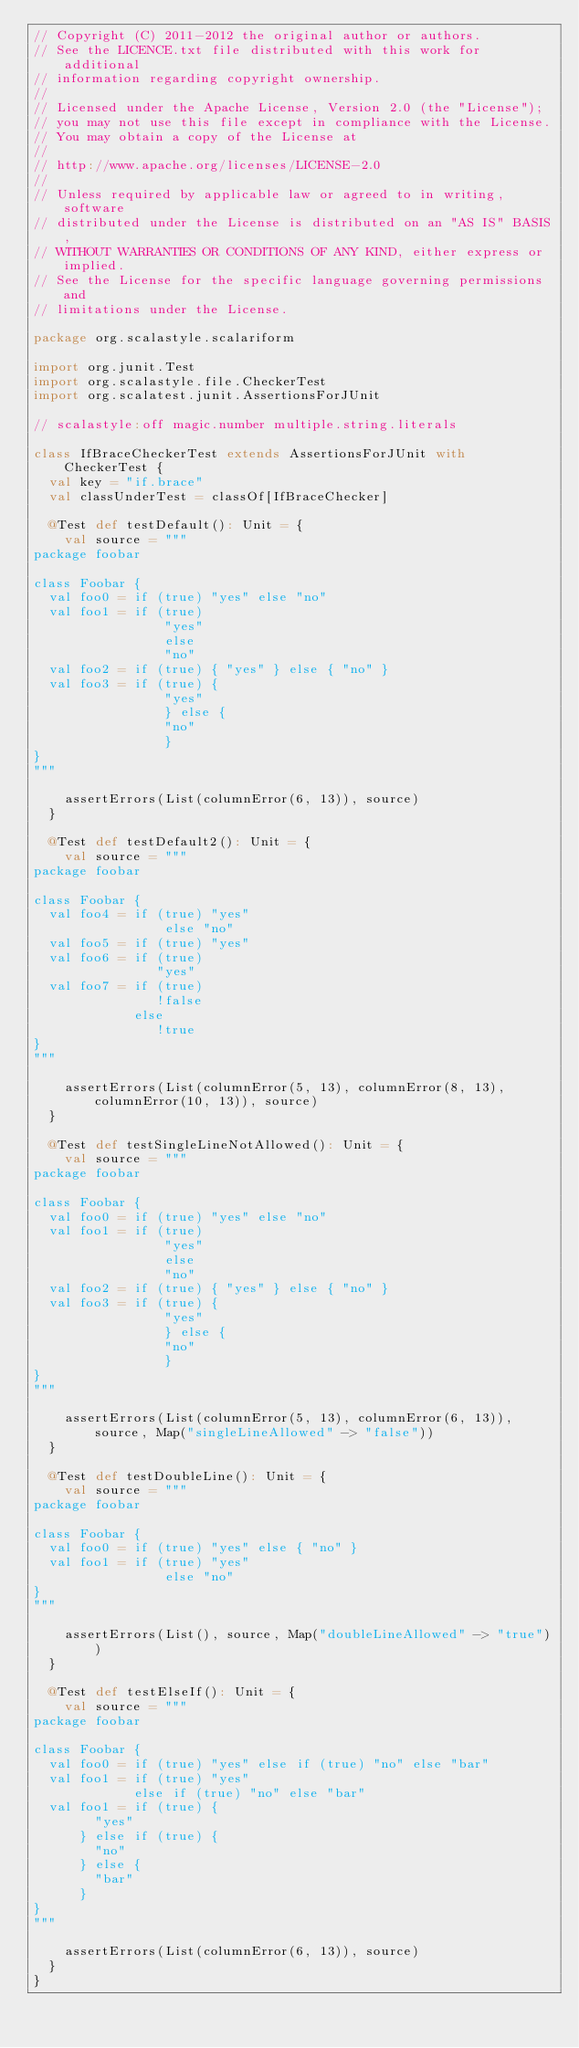Convert code to text. <code><loc_0><loc_0><loc_500><loc_500><_Scala_>// Copyright (C) 2011-2012 the original author or authors.
// See the LICENCE.txt file distributed with this work for additional
// information regarding copyright ownership.
//
// Licensed under the Apache License, Version 2.0 (the "License");
// you may not use this file except in compliance with the License.
// You may obtain a copy of the License at
//
// http://www.apache.org/licenses/LICENSE-2.0
//
// Unless required by applicable law or agreed to in writing, software
// distributed under the License is distributed on an "AS IS" BASIS,
// WITHOUT WARRANTIES OR CONDITIONS OF ANY KIND, either express or implied.
// See the License for the specific language governing permissions and
// limitations under the License.

package org.scalastyle.scalariform

import org.junit.Test
import org.scalastyle.file.CheckerTest
import org.scalatest.junit.AssertionsForJUnit

// scalastyle:off magic.number multiple.string.literals

class IfBraceCheckerTest extends AssertionsForJUnit with CheckerTest {
  val key = "if.brace"
  val classUnderTest = classOf[IfBraceChecker]

  @Test def testDefault(): Unit = {
    val source = """
package foobar

class Foobar {
  val foo0 = if (true) "yes" else "no"
  val foo1 = if (true)
                 "yes"
                 else
                 "no"
  val foo2 = if (true) { "yes" } else { "no" }
  val foo3 = if (true) {
                 "yes"
                 } else {
                 "no"
                 }
}
"""

    assertErrors(List(columnError(6, 13)), source)
  }

  @Test def testDefault2(): Unit = {
    val source = """
package foobar

class Foobar {
  val foo4 = if (true) "yes"
                 else "no"
  val foo5 = if (true) "yes"
  val foo6 = if (true)
                "yes"
  val foo7 = if (true)
                !false
             else
                !true
}
"""

    assertErrors(List(columnError(5, 13), columnError(8, 13), columnError(10, 13)), source)
  }

  @Test def testSingleLineNotAllowed(): Unit = {
    val source = """
package foobar

class Foobar {
  val foo0 = if (true) "yes" else "no"
  val foo1 = if (true)
                 "yes"
                 else
                 "no"
  val foo2 = if (true) { "yes" } else { "no" }
  val foo3 = if (true) {
                 "yes"
                 } else {
                 "no"
                 }
}
"""

    assertErrors(List(columnError(5, 13), columnError(6, 13)), source, Map("singleLineAllowed" -> "false"))
  }

  @Test def testDoubleLine(): Unit = {
    val source = """
package foobar

class Foobar {
  val foo0 = if (true) "yes" else { "no" }
  val foo1 = if (true) "yes"
                 else "no"
}
"""

    assertErrors(List(), source, Map("doubleLineAllowed" -> "true"))
  }

  @Test def testElseIf(): Unit = {
    val source = """
package foobar

class Foobar {
  val foo0 = if (true) "yes" else if (true) "no" else "bar"
  val foo1 = if (true) "yes"
             else if (true) "no" else "bar"
  val foo1 = if (true) {
        "yes"
      } else if (true) {
        "no"
      } else {
        "bar"
      }
}
"""

    assertErrors(List(columnError(6, 13)), source)
  }
}
</code> 